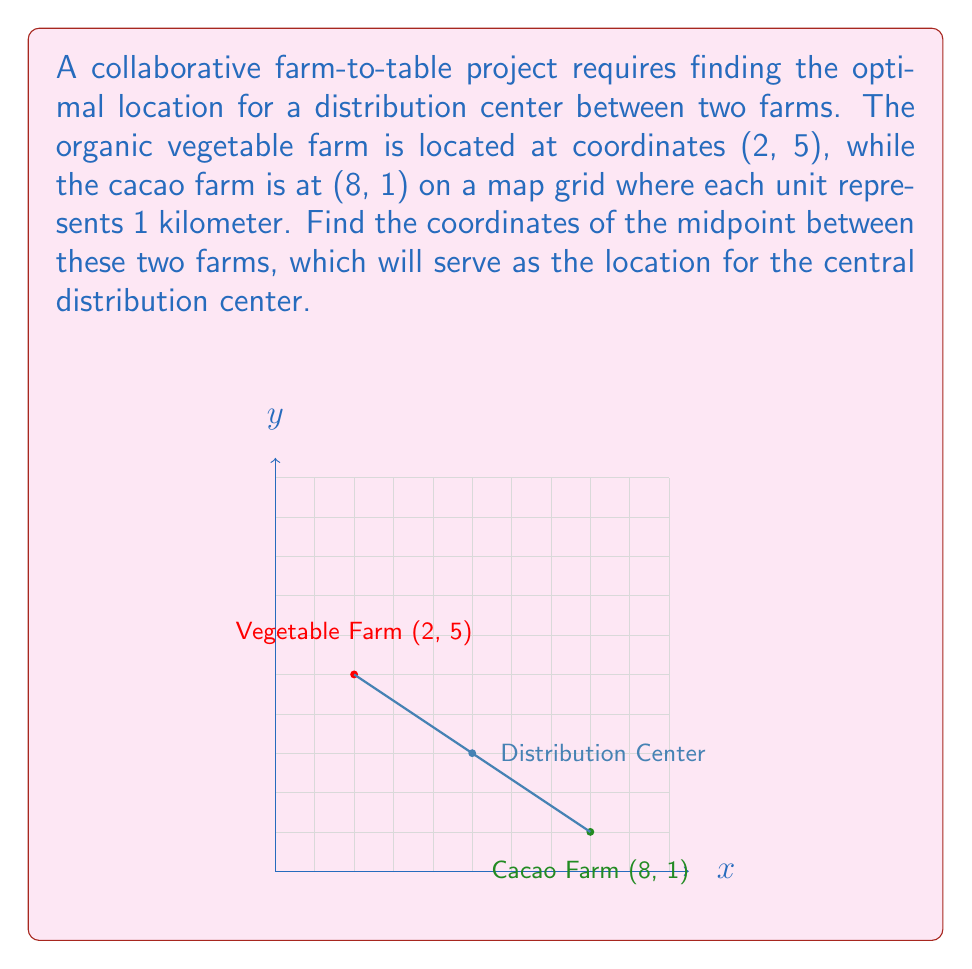Can you solve this math problem? To find the midpoint between two points, we use the midpoint formula:

$$ \text{Midpoint} = \left(\frac{x_1 + x_2}{2}, \frac{y_1 + y_2}{2}\right) $$

Where $(x_1, y_1)$ are the coordinates of the first point and $(x_2, y_2)$ are the coordinates of the second point.

For our problem:
- Vegetable farm: $(x_1, y_1) = (2, 5)$
- Cacao farm: $(x_2, y_2) = (8, 1)$

Let's calculate the x-coordinate of the midpoint:
$$ x = \frac{x_1 + x_2}{2} = \frac{2 + 8}{2} = \frac{10}{2} = 5 $$

Now, let's calculate the y-coordinate of the midpoint:
$$ y = \frac{y_1 + y_2}{2} = \frac{5 + 1}{2} = \frac{6}{2} = 3 $$

Therefore, the coordinates of the midpoint, which will be the location of the distribution center, are (5, 3).
Answer: (5, 3) 